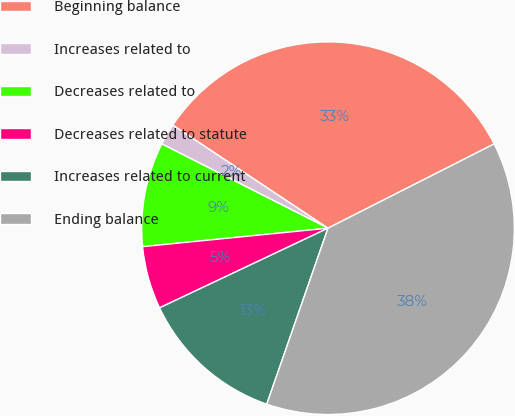<chart> <loc_0><loc_0><loc_500><loc_500><pie_chart><fcel>Beginning balance<fcel>Increases related to<fcel>Decreases related to<fcel>Decreases related to statute<fcel>Increases related to current<fcel>Ending balance<nl><fcel>33.2%<fcel>1.86%<fcel>9.05%<fcel>5.45%<fcel>12.64%<fcel>37.8%<nl></chart> 